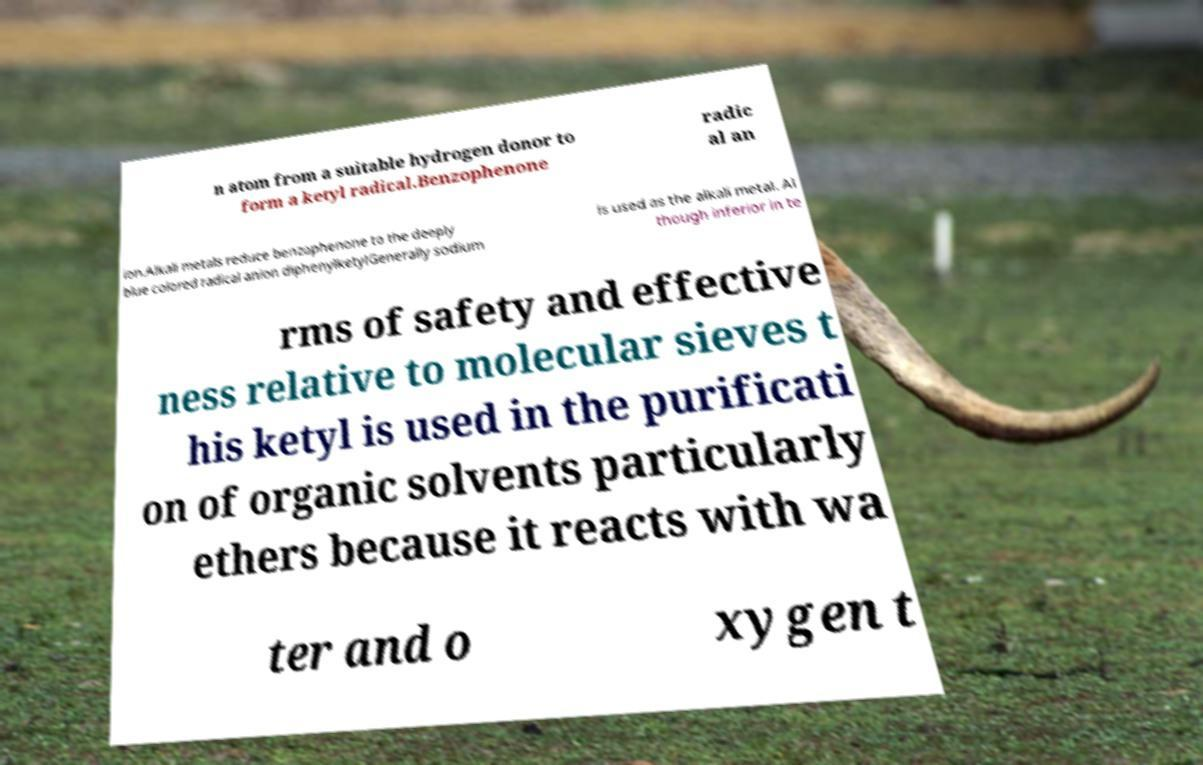There's text embedded in this image that I need extracted. Can you transcribe it verbatim? n atom from a suitable hydrogen donor to form a ketyl radical.Benzophenone radic al an ion.Alkali metals reduce benzophenone to the deeply blue colored radical anion diphenylketylGenerally sodium is used as the alkali metal. Al though inferior in te rms of safety and effective ness relative to molecular sieves t his ketyl is used in the purificati on of organic solvents particularly ethers because it reacts with wa ter and o xygen t 